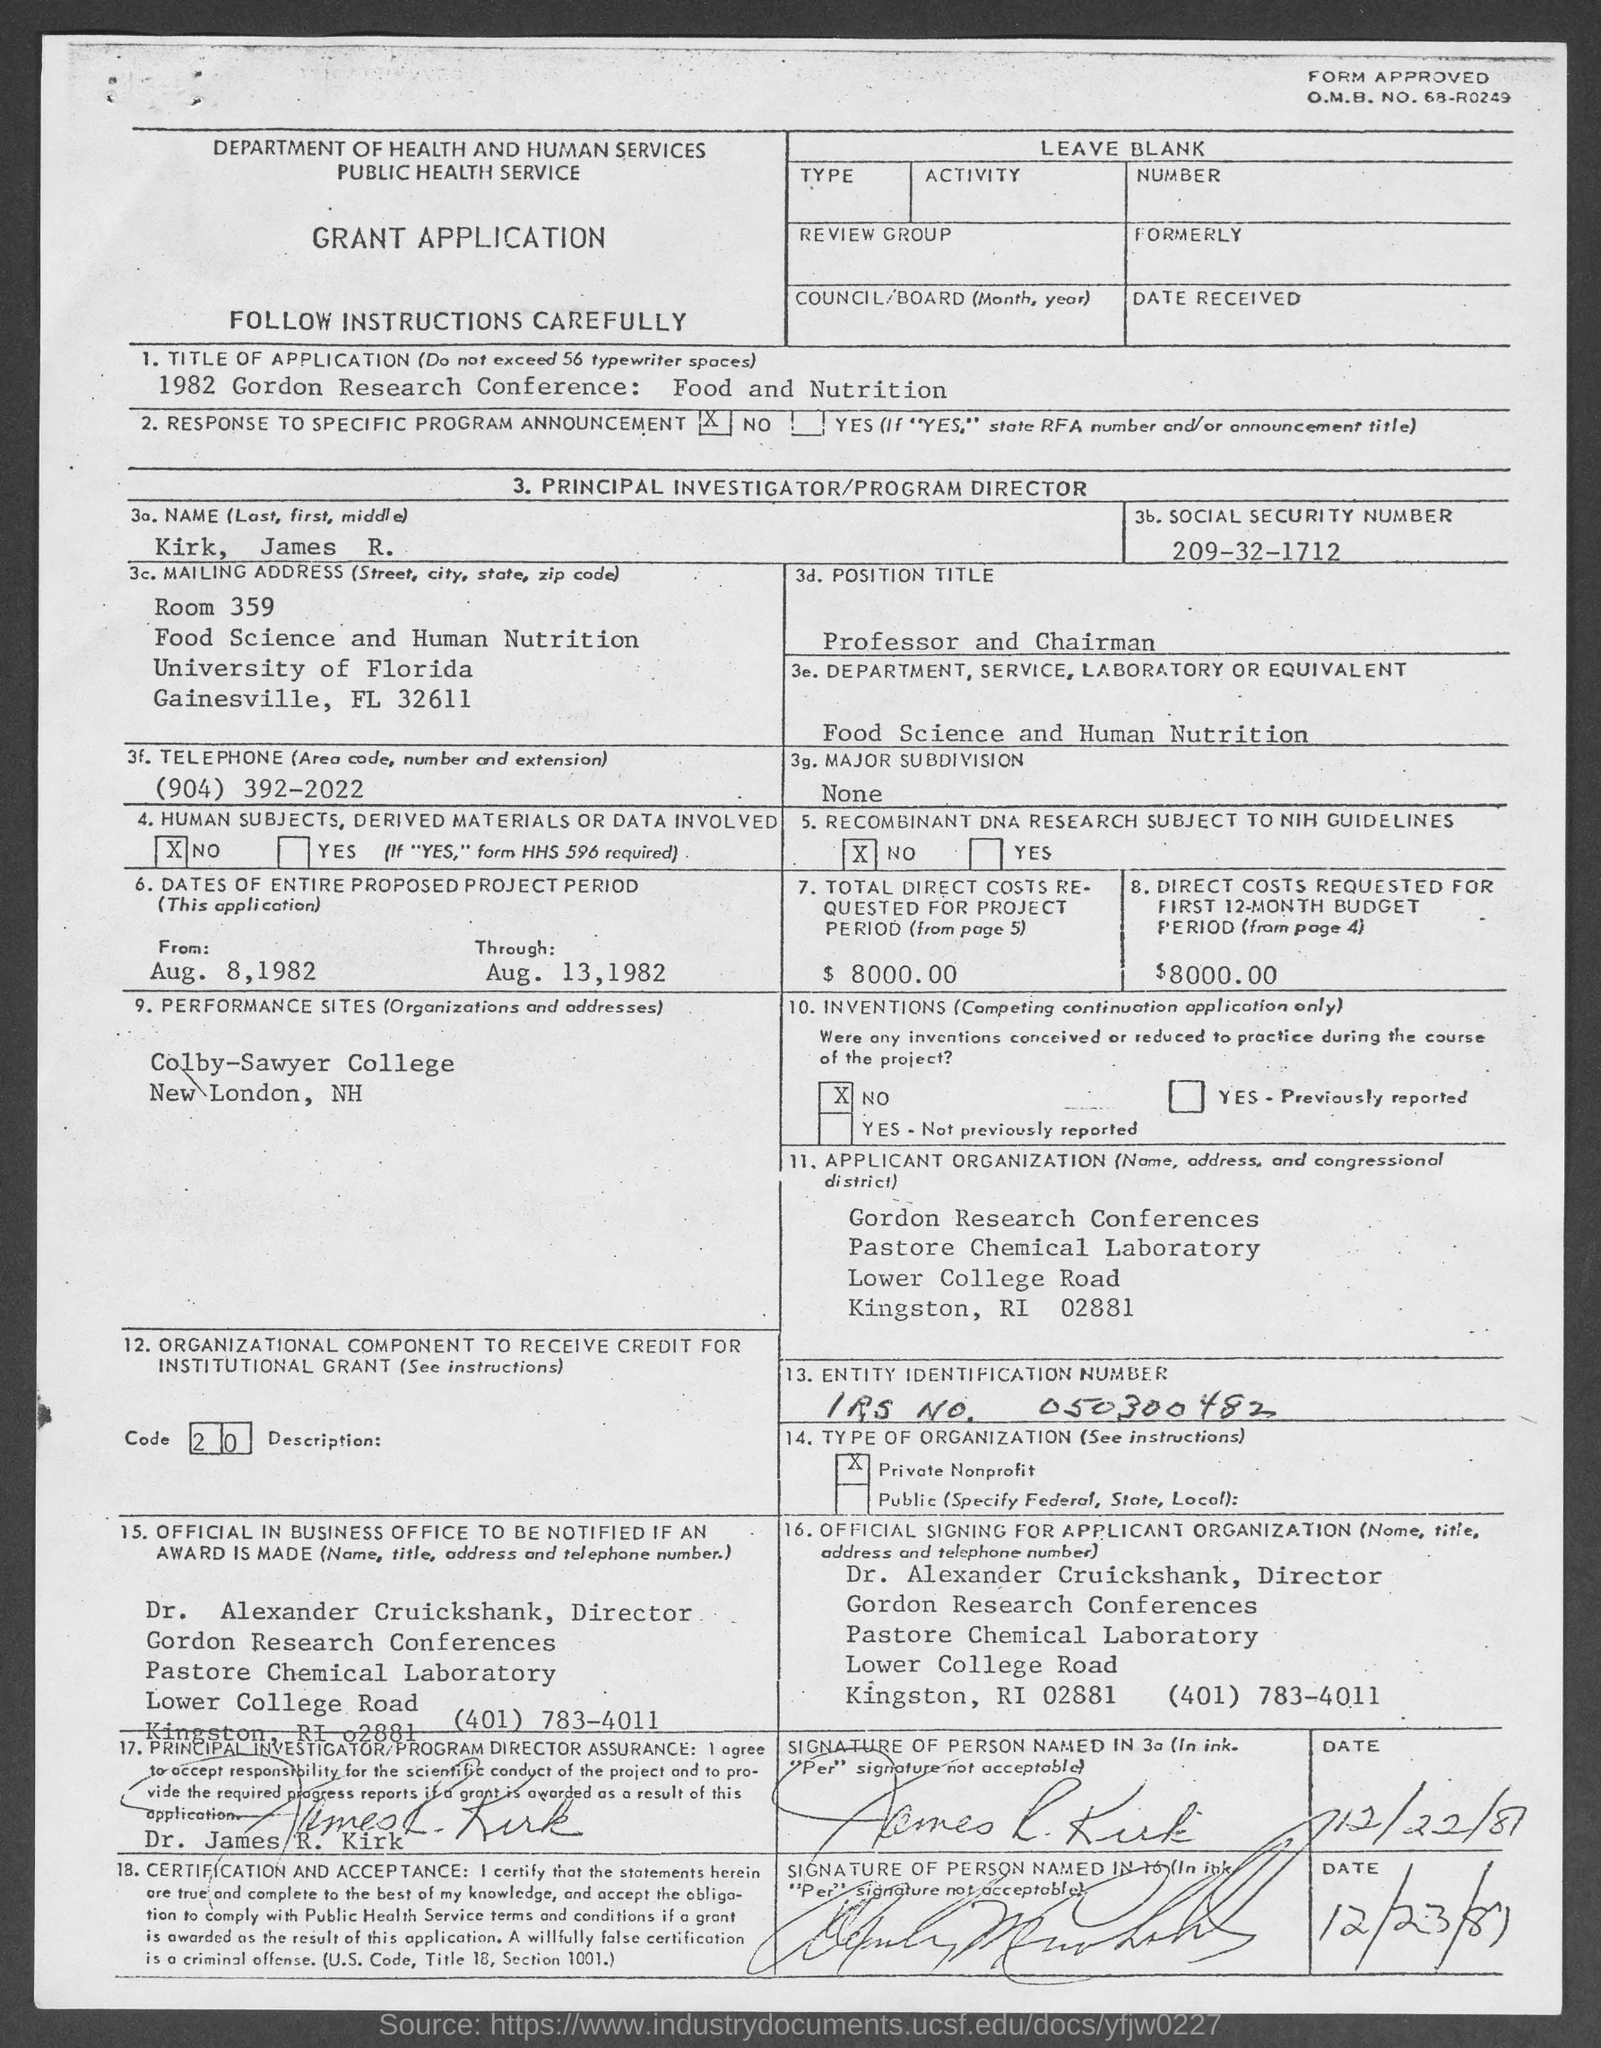What is the o.m.b. no. ?
Give a very brief answer. 68-R0249. What is the name of principal investigator?
Your response must be concise. Kirk, James R. What is the social security number ?
Ensure brevity in your answer.  209-32-1712. In which state is university of florida?
Your answer should be compact. Florida. What is the total direct costs requested for project period ?
Offer a very short reply. 8000.00. What is the direct costs requested for first 12-month budget period ?
Your answer should be compact. $8000.00. What is the position of dr. alexander cruickshank?
Your answer should be compact. Director. What is the telephone number of dr. alexander cruickshank ?
Your answer should be very brief. (401) 783-4011. 